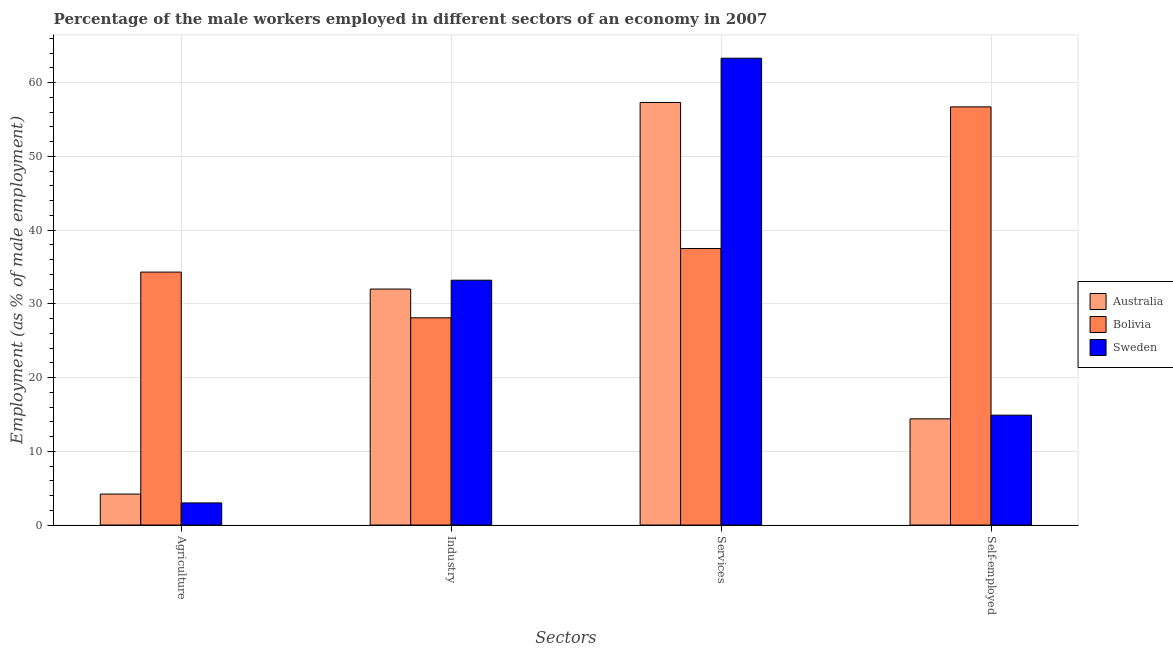How many bars are there on the 1st tick from the right?
Provide a short and direct response. 3. What is the label of the 1st group of bars from the left?
Offer a terse response. Agriculture. What is the percentage of male workers in industry in Bolivia?
Provide a succinct answer. 28.1. Across all countries, what is the maximum percentage of male workers in services?
Make the answer very short. 63.3. Across all countries, what is the minimum percentage of male workers in services?
Ensure brevity in your answer.  37.5. In which country was the percentage of self employed male workers maximum?
Ensure brevity in your answer.  Bolivia. What is the total percentage of male workers in agriculture in the graph?
Give a very brief answer. 41.5. What is the difference between the percentage of male workers in agriculture in Australia and that in Bolivia?
Give a very brief answer. -30.1. What is the difference between the percentage of self employed male workers in Sweden and the percentage of male workers in agriculture in Australia?
Your answer should be compact. 10.7. What is the average percentage of male workers in agriculture per country?
Offer a very short reply. 13.83. What is the difference between the percentage of male workers in industry and percentage of male workers in agriculture in Bolivia?
Your answer should be compact. -6.2. What is the ratio of the percentage of male workers in services in Australia to that in Bolivia?
Your response must be concise. 1.53. Is the percentage of self employed male workers in Bolivia less than that in Australia?
Ensure brevity in your answer.  No. Is the difference between the percentage of self employed male workers in Australia and Sweden greater than the difference between the percentage of male workers in services in Australia and Sweden?
Provide a succinct answer. Yes. What is the difference between the highest and the lowest percentage of male workers in industry?
Your answer should be very brief. 5.1. In how many countries, is the percentage of self employed male workers greater than the average percentage of self employed male workers taken over all countries?
Your answer should be compact. 1. Is the sum of the percentage of male workers in industry in Sweden and Australia greater than the maximum percentage of self employed male workers across all countries?
Offer a terse response. Yes. Is it the case that in every country, the sum of the percentage of male workers in agriculture and percentage of male workers in industry is greater than the percentage of male workers in services?
Give a very brief answer. No. How many bars are there?
Offer a very short reply. 12. What is the difference between two consecutive major ticks on the Y-axis?
Your answer should be very brief. 10. Does the graph contain any zero values?
Your answer should be very brief. No. What is the title of the graph?
Provide a succinct answer. Percentage of the male workers employed in different sectors of an economy in 2007. What is the label or title of the X-axis?
Provide a short and direct response. Sectors. What is the label or title of the Y-axis?
Offer a terse response. Employment (as % of male employment). What is the Employment (as % of male employment) of Australia in Agriculture?
Provide a succinct answer. 4.2. What is the Employment (as % of male employment) of Bolivia in Agriculture?
Your answer should be very brief. 34.3. What is the Employment (as % of male employment) in Bolivia in Industry?
Offer a very short reply. 28.1. What is the Employment (as % of male employment) of Sweden in Industry?
Ensure brevity in your answer.  33.2. What is the Employment (as % of male employment) in Australia in Services?
Make the answer very short. 57.3. What is the Employment (as % of male employment) in Bolivia in Services?
Your answer should be very brief. 37.5. What is the Employment (as % of male employment) in Sweden in Services?
Keep it short and to the point. 63.3. What is the Employment (as % of male employment) in Australia in Self-employed?
Make the answer very short. 14.4. What is the Employment (as % of male employment) of Bolivia in Self-employed?
Your response must be concise. 56.7. What is the Employment (as % of male employment) in Sweden in Self-employed?
Provide a short and direct response. 14.9. Across all Sectors, what is the maximum Employment (as % of male employment) of Australia?
Ensure brevity in your answer.  57.3. Across all Sectors, what is the maximum Employment (as % of male employment) of Bolivia?
Keep it short and to the point. 56.7. Across all Sectors, what is the maximum Employment (as % of male employment) of Sweden?
Your answer should be compact. 63.3. Across all Sectors, what is the minimum Employment (as % of male employment) in Australia?
Ensure brevity in your answer.  4.2. Across all Sectors, what is the minimum Employment (as % of male employment) in Bolivia?
Provide a succinct answer. 28.1. What is the total Employment (as % of male employment) in Australia in the graph?
Ensure brevity in your answer.  107.9. What is the total Employment (as % of male employment) of Bolivia in the graph?
Ensure brevity in your answer.  156.6. What is the total Employment (as % of male employment) in Sweden in the graph?
Provide a short and direct response. 114.4. What is the difference between the Employment (as % of male employment) of Australia in Agriculture and that in Industry?
Keep it short and to the point. -27.8. What is the difference between the Employment (as % of male employment) in Bolivia in Agriculture and that in Industry?
Your answer should be very brief. 6.2. What is the difference between the Employment (as % of male employment) of Sweden in Agriculture and that in Industry?
Your answer should be very brief. -30.2. What is the difference between the Employment (as % of male employment) of Australia in Agriculture and that in Services?
Offer a very short reply. -53.1. What is the difference between the Employment (as % of male employment) in Bolivia in Agriculture and that in Services?
Your response must be concise. -3.2. What is the difference between the Employment (as % of male employment) in Sweden in Agriculture and that in Services?
Provide a succinct answer. -60.3. What is the difference between the Employment (as % of male employment) in Australia in Agriculture and that in Self-employed?
Offer a terse response. -10.2. What is the difference between the Employment (as % of male employment) in Bolivia in Agriculture and that in Self-employed?
Give a very brief answer. -22.4. What is the difference between the Employment (as % of male employment) in Australia in Industry and that in Services?
Offer a terse response. -25.3. What is the difference between the Employment (as % of male employment) in Sweden in Industry and that in Services?
Keep it short and to the point. -30.1. What is the difference between the Employment (as % of male employment) in Bolivia in Industry and that in Self-employed?
Your answer should be compact. -28.6. What is the difference between the Employment (as % of male employment) of Sweden in Industry and that in Self-employed?
Your answer should be very brief. 18.3. What is the difference between the Employment (as % of male employment) in Australia in Services and that in Self-employed?
Your answer should be very brief. 42.9. What is the difference between the Employment (as % of male employment) of Bolivia in Services and that in Self-employed?
Ensure brevity in your answer.  -19.2. What is the difference between the Employment (as % of male employment) of Sweden in Services and that in Self-employed?
Offer a very short reply. 48.4. What is the difference between the Employment (as % of male employment) in Australia in Agriculture and the Employment (as % of male employment) in Bolivia in Industry?
Provide a succinct answer. -23.9. What is the difference between the Employment (as % of male employment) in Australia in Agriculture and the Employment (as % of male employment) in Bolivia in Services?
Your response must be concise. -33.3. What is the difference between the Employment (as % of male employment) of Australia in Agriculture and the Employment (as % of male employment) of Sweden in Services?
Offer a terse response. -59.1. What is the difference between the Employment (as % of male employment) of Bolivia in Agriculture and the Employment (as % of male employment) of Sweden in Services?
Offer a terse response. -29. What is the difference between the Employment (as % of male employment) of Australia in Agriculture and the Employment (as % of male employment) of Bolivia in Self-employed?
Make the answer very short. -52.5. What is the difference between the Employment (as % of male employment) in Bolivia in Agriculture and the Employment (as % of male employment) in Sweden in Self-employed?
Ensure brevity in your answer.  19.4. What is the difference between the Employment (as % of male employment) of Australia in Industry and the Employment (as % of male employment) of Sweden in Services?
Provide a short and direct response. -31.3. What is the difference between the Employment (as % of male employment) in Bolivia in Industry and the Employment (as % of male employment) in Sweden in Services?
Provide a succinct answer. -35.2. What is the difference between the Employment (as % of male employment) in Australia in Industry and the Employment (as % of male employment) in Bolivia in Self-employed?
Ensure brevity in your answer.  -24.7. What is the difference between the Employment (as % of male employment) in Australia in Industry and the Employment (as % of male employment) in Sweden in Self-employed?
Your answer should be very brief. 17.1. What is the difference between the Employment (as % of male employment) in Bolivia in Industry and the Employment (as % of male employment) in Sweden in Self-employed?
Keep it short and to the point. 13.2. What is the difference between the Employment (as % of male employment) of Australia in Services and the Employment (as % of male employment) of Bolivia in Self-employed?
Offer a terse response. 0.6. What is the difference between the Employment (as % of male employment) in Australia in Services and the Employment (as % of male employment) in Sweden in Self-employed?
Your response must be concise. 42.4. What is the difference between the Employment (as % of male employment) in Bolivia in Services and the Employment (as % of male employment) in Sweden in Self-employed?
Offer a terse response. 22.6. What is the average Employment (as % of male employment) of Australia per Sectors?
Your answer should be very brief. 26.98. What is the average Employment (as % of male employment) in Bolivia per Sectors?
Ensure brevity in your answer.  39.15. What is the average Employment (as % of male employment) of Sweden per Sectors?
Your response must be concise. 28.6. What is the difference between the Employment (as % of male employment) in Australia and Employment (as % of male employment) in Bolivia in Agriculture?
Ensure brevity in your answer.  -30.1. What is the difference between the Employment (as % of male employment) of Australia and Employment (as % of male employment) of Sweden in Agriculture?
Provide a short and direct response. 1.2. What is the difference between the Employment (as % of male employment) in Bolivia and Employment (as % of male employment) in Sweden in Agriculture?
Keep it short and to the point. 31.3. What is the difference between the Employment (as % of male employment) in Australia and Employment (as % of male employment) in Bolivia in Industry?
Keep it short and to the point. 3.9. What is the difference between the Employment (as % of male employment) in Bolivia and Employment (as % of male employment) in Sweden in Industry?
Ensure brevity in your answer.  -5.1. What is the difference between the Employment (as % of male employment) in Australia and Employment (as % of male employment) in Bolivia in Services?
Your answer should be very brief. 19.8. What is the difference between the Employment (as % of male employment) of Australia and Employment (as % of male employment) of Sweden in Services?
Your response must be concise. -6. What is the difference between the Employment (as % of male employment) of Bolivia and Employment (as % of male employment) of Sweden in Services?
Your response must be concise. -25.8. What is the difference between the Employment (as % of male employment) of Australia and Employment (as % of male employment) of Bolivia in Self-employed?
Your response must be concise. -42.3. What is the difference between the Employment (as % of male employment) in Australia and Employment (as % of male employment) in Sweden in Self-employed?
Ensure brevity in your answer.  -0.5. What is the difference between the Employment (as % of male employment) in Bolivia and Employment (as % of male employment) in Sweden in Self-employed?
Provide a succinct answer. 41.8. What is the ratio of the Employment (as % of male employment) of Australia in Agriculture to that in Industry?
Ensure brevity in your answer.  0.13. What is the ratio of the Employment (as % of male employment) in Bolivia in Agriculture to that in Industry?
Make the answer very short. 1.22. What is the ratio of the Employment (as % of male employment) of Sweden in Agriculture to that in Industry?
Your answer should be very brief. 0.09. What is the ratio of the Employment (as % of male employment) of Australia in Agriculture to that in Services?
Offer a very short reply. 0.07. What is the ratio of the Employment (as % of male employment) in Bolivia in Agriculture to that in Services?
Offer a terse response. 0.91. What is the ratio of the Employment (as % of male employment) of Sweden in Agriculture to that in Services?
Your answer should be compact. 0.05. What is the ratio of the Employment (as % of male employment) of Australia in Agriculture to that in Self-employed?
Offer a terse response. 0.29. What is the ratio of the Employment (as % of male employment) of Bolivia in Agriculture to that in Self-employed?
Offer a terse response. 0.6. What is the ratio of the Employment (as % of male employment) of Sweden in Agriculture to that in Self-employed?
Your answer should be very brief. 0.2. What is the ratio of the Employment (as % of male employment) in Australia in Industry to that in Services?
Offer a terse response. 0.56. What is the ratio of the Employment (as % of male employment) in Bolivia in Industry to that in Services?
Offer a very short reply. 0.75. What is the ratio of the Employment (as % of male employment) of Sweden in Industry to that in Services?
Provide a short and direct response. 0.52. What is the ratio of the Employment (as % of male employment) of Australia in Industry to that in Self-employed?
Your answer should be compact. 2.22. What is the ratio of the Employment (as % of male employment) in Bolivia in Industry to that in Self-employed?
Offer a terse response. 0.5. What is the ratio of the Employment (as % of male employment) of Sweden in Industry to that in Self-employed?
Provide a succinct answer. 2.23. What is the ratio of the Employment (as % of male employment) of Australia in Services to that in Self-employed?
Offer a very short reply. 3.98. What is the ratio of the Employment (as % of male employment) of Bolivia in Services to that in Self-employed?
Provide a succinct answer. 0.66. What is the ratio of the Employment (as % of male employment) of Sweden in Services to that in Self-employed?
Offer a very short reply. 4.25. What is the difference between the highest and the second highest Employment (as % of male employment) in Australia?
Provide a succinct answer. 25.3. What is the difference between the highest and the second highest Employment (as % of male employment) of Sweden?
Make the answer very short. 30.1. What is the difference between the highest and the lowest Employment (as % of male employment) in Australia?
Keep it short and to the point. 53.1. What is the difference between the highest and the lowest Employment (as % of male employment) of Bolivia?
Give a very brief answer. 28.6. What is the difference between the highest and the lowest Employment (as % of male employment) in Sweden?
Ensure brevity in your answer.  60.3. 